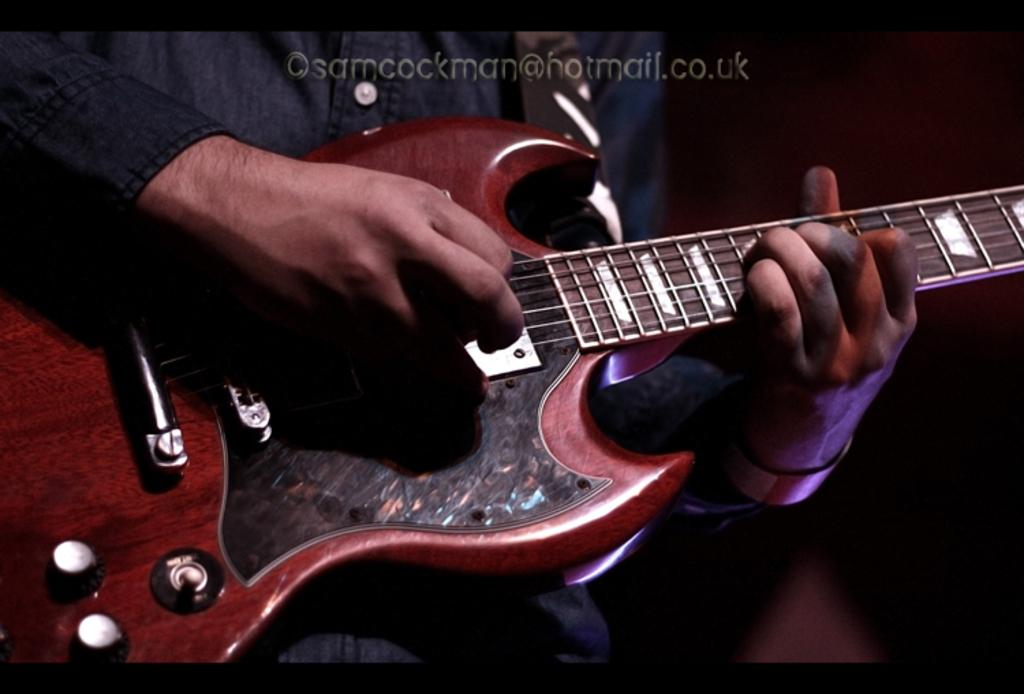What is the main subject of the image? There is a person in the image. What is the person doing in the image? The person is playing the guitar. What type of good-bye message is the person sending in the image? There is no indication in the image that the person is sending a good-bye message. What is the condition of the person's wrist in the image? The image does not show the person's wrist, so it cannot be determined from the image. 